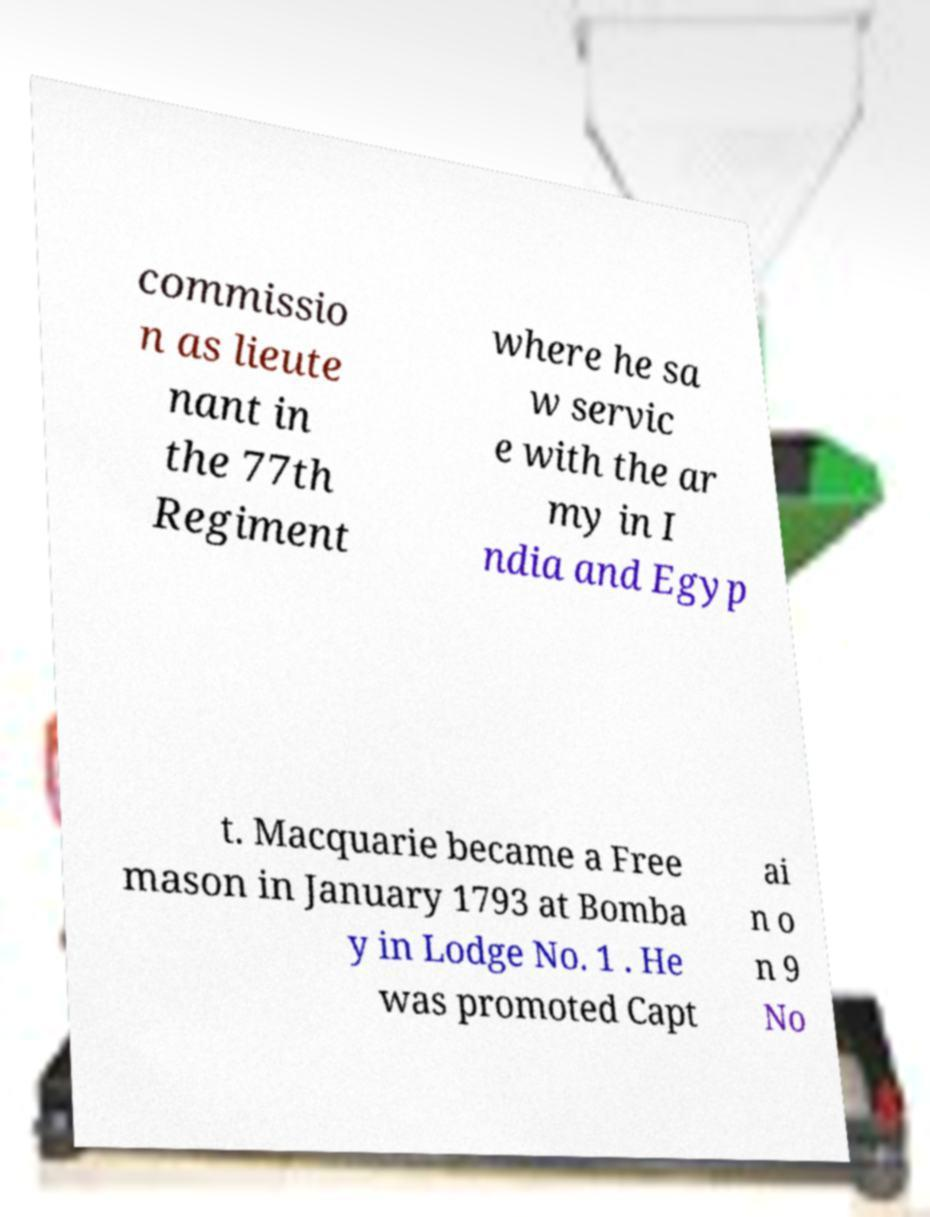Can you accurately transcribe the text from the provided image for me? commissio n as lieute nant in the 77th Regiment where he sa w servic e with the ar my in I ndia and Egyp t. Macquarie became a Free mason in January 1793 at Bomba y in Lodge No. 1 . He was promoted Capt ai n o n 9 No 